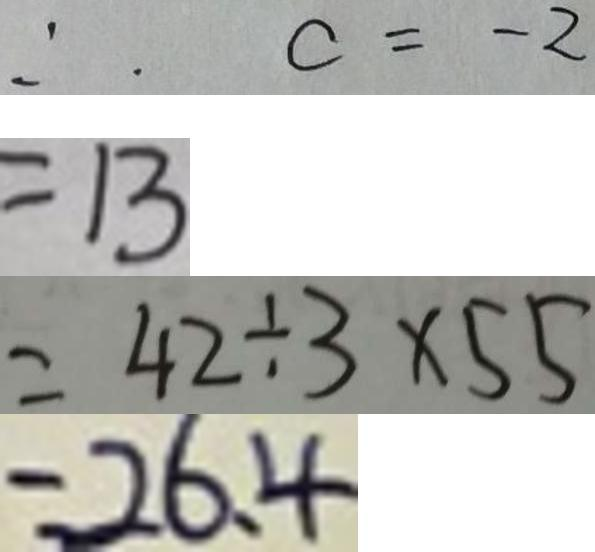Convert formula to latex. <formula><loc_0><loc_0><loc_500><loc_500>\therefore c = - 2 
 = 1 3 
 = 4 2 \div 3 \times 5 5 
 = 2 6 . 4</formula> 